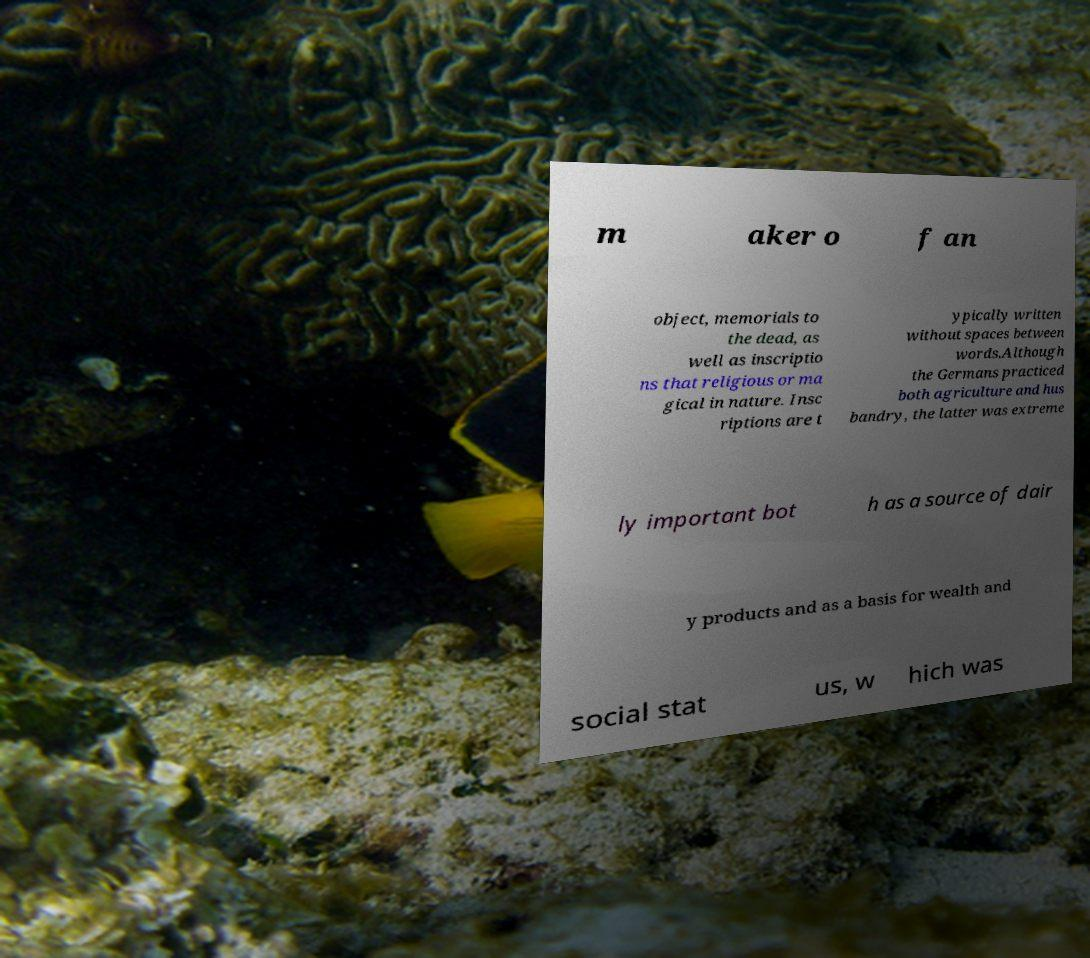Could you extract and type out the text from this image? m aker o f an object, memorials to the dead, as well as inscriptio ns that religious or ma gical in nature. Insc riptions are t ypically written without spaces between words.Although the Germans practiced both agriculture and hus bandry, the latter was extreme ly important bot h as a source of dair y products and as a basis for wealth and social stat us, w hich was 